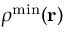<formula> <loc_0><loc_0><loc_500><loc_500>{ \boldsymbol \rho } ^ { \min } ( { r } )</formula> 